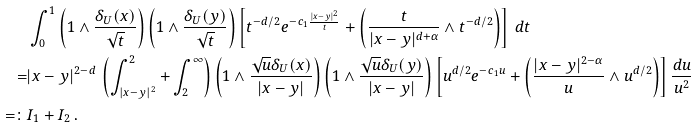Convert formula to latex. <formula><loc_0><loc_0><loc_500><loc_500>& \int _ { 0 } ^ { 1 } \left ( 1 \wedge \frac { \delta _ { U } ( x ) } { \sqrt { t } } \right ) \left ( 1 \wedge \frac { \delta _ { U } ( y ) } { \sqrt { t } } \right ) \left [ t ^ { - d / 2 } e ^ { - c _ { 1 } \frac { | x - y | ^ { 2 } } { t } } + \left ( \frac { t } { | x - y | ^ { d + \alpha } } \wedge t ^ { - d / 2 } \right ) \right ] \, d t \\ = & | x - y | ^ { 2 - d } \, \left ( \int _ { | x - y | ^ { 2 } } ^ { 2 } + \int _ { 2 } ^ { \infty } \right ) \left ( 1 \wedge \frac { \sqrt { u } \delta _ { U } ( x ) } { | x - y | } \right ) \left ( 1 \wedge \frac { \sqrt { u } \delta _ { U } ( y ) } { | x - y | } \right ) \left [ u ^ { d / 2 } e ^ { - c _ { 1 } u } + \left ( \frac { | x - y | ^ { 2 - \alpha } } { u } \wedge u ^ { d / 2 } \right ) \right ] \frac { d u } { u ^ { 2 } } \\ = \colon & I _ { 1 } + I _ { 2 } \, .</formula> 